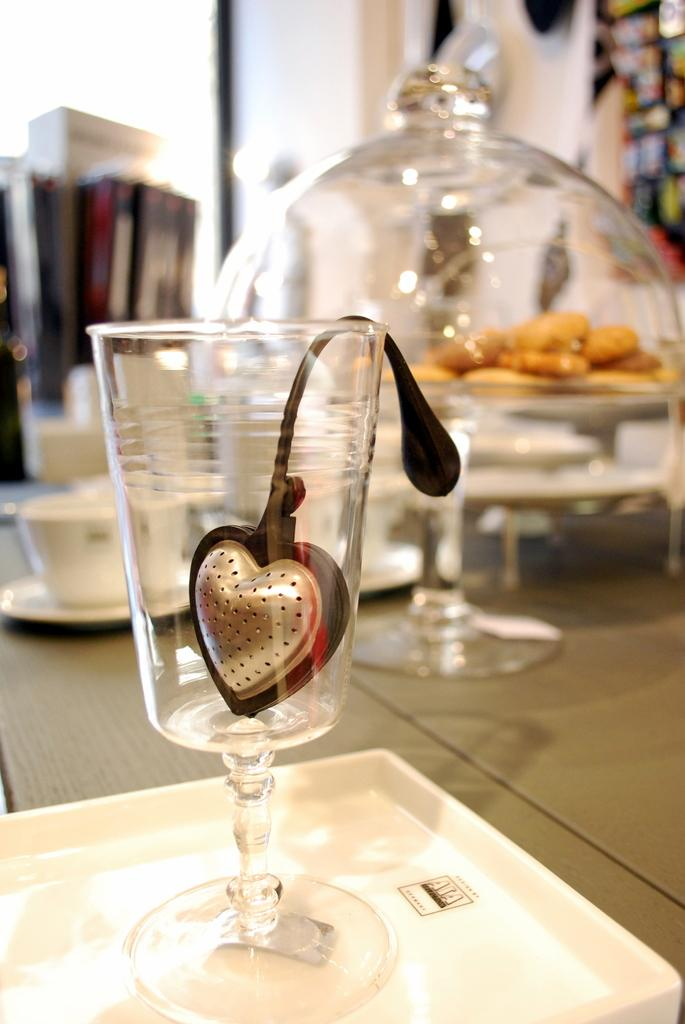What piece of furniture is present in the image? There is a table in the image. What items can be seen on the table? There are glasses, food items on a plate, and cups on the table. What type of tray is on the table? There is a white color tray on the table. What can be seen in the background of the image? There is a wall in the background of the image. What type of cart is visible in the image? There is no cart present in the image. Is there a ring on the table in the image? There is no ring visible on the table in the image. 